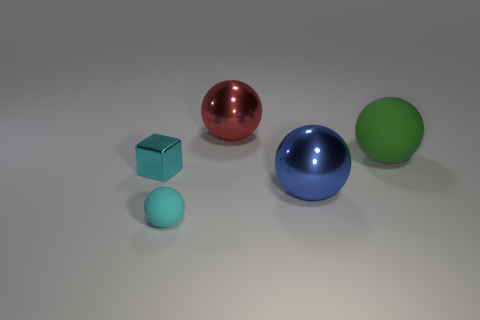Subtract all small cyan rubber spheres. How many spheres are left? 3 Add 3 big purple blocks. How many objects exist? 8 Subtract all blue balls. How many balls are left? 3 Subtract all blocks. How many objects are left? 4 Subtract all red shiny balls. Subtract all green objects. How many objects are left? 3 Add 1 big blue metal spheres. How many big blue metal spheres are left? 2 Add 1 large rubber things. How many large rubber things exist? 2 Subtract 0 red cylinders. How many objects are left? 5 Subtract all red cubes. Subtract all gray cylinders. How many cubes are left? 1 